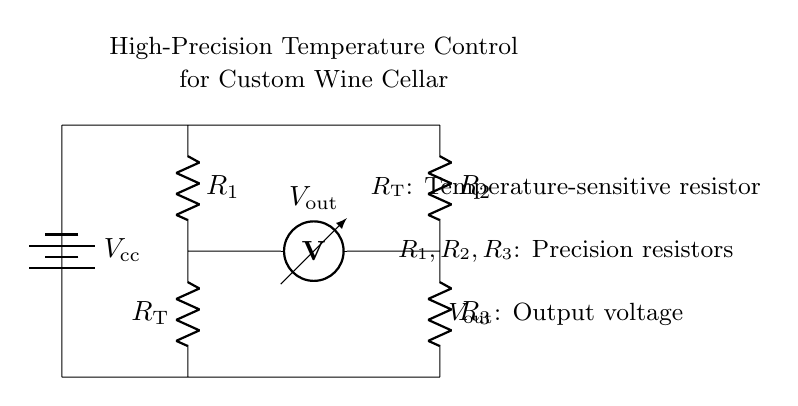What is the type of resistor labeled R_T? R_T is a temperature-sensitive resistor used for measuring temperature variations. It plays a crucial role in the Wheatstone bridge for detecting temperature changes.
Answer: temperature-sensitive resistor What is the function of V_out in this circuit? V_out is the output voltage, which indicates the difference in voltage across the bridge. It is used to monitor or control the temperature within the system.
Answer: output voltage How many precision resistors are in this circuit? There are three precision resistors: R_1, R_2, and R_3. They are used to balance the bridge and ensure accurate measurements.
Answer: three What is the purpose of the Wheatstone bridge in this application? The Wheatstone bridge is used for precise measurement of resistance changes due to temperature variations. This allows for high-precision temperature control, essential for maintaining the desired conditions in a wine cellar.
Answer: precise measurement What does the voltage source V_cc represent? V_cc represents the supply voltage needed to power the Wheatstone bridge circuit, providing the necessary energy for operation.
Answer: supply voltage What occurs when R_T changes resistance? When R_T changes its resistance due to temperature variations, it causes a change in the output voltage V_out, which can be used to control the temperature in the wine cellar.
Answer: change in output voltage 